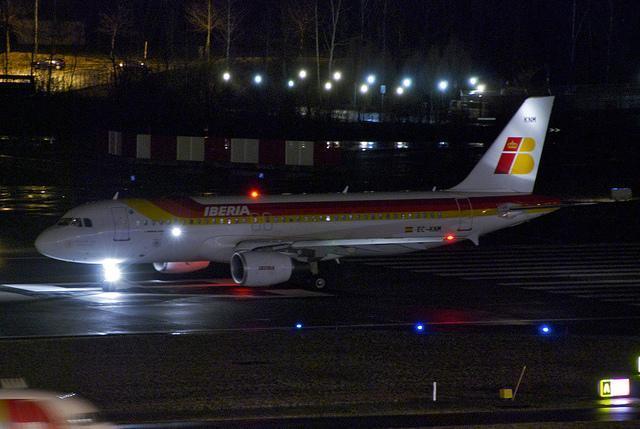How many engines are visible?
Give a very brief answer. 2. How many knives are on the magnetic knife rack?
Give a very brief answer. 0. 